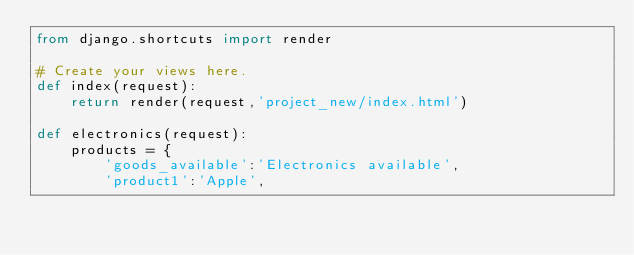Convert code to text. <code><loc_0><loc_0><loc_500><loc_500><_Python_>from django.shortcuts import render

# Create your views here.
def index(request):
    return render(request,'project_new/index.html')

def electronics(request):
    products = {
        'goods_available':'Electronics available',
        'product1':'Apple',</code> 